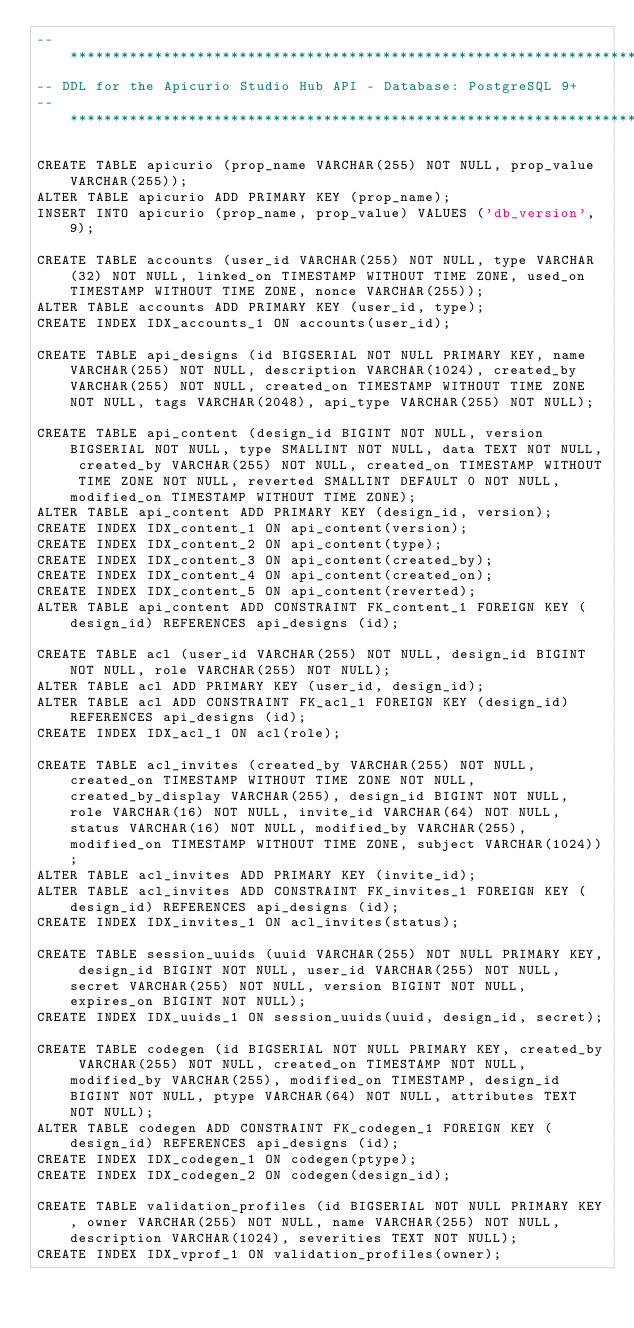Convert code to text. <code><loc_0><loc_0><loc_500><loc_500><_SQL_>-- *********************************************************************
-- DDL for the Apicurio Studio Hub API - Database: PostgreSQL 9+
-- *********************************************************************

CREATE TABLE apicurio (prop_name VARCHAR(255) NOT NULL, prop_value VARCHAR(255));
ALTER TABLE apicurio ADD PRIMARY KEY (prop_name);
INSERT INTO apicurio (prop_name, prop_value) VALUES ('db_version', 9);

CREATE TABLE accounts (user_id VARCHAR(255) NOT NULL, type VARCHAR(32) NOT NULL, linked_on TIMESTAMP WITHOUT TIME ZONE, used_on TIMESTAMP WITHOUT TIME ZONE, nonce VARCHAR(255));
ALTER TABLE accounts ADD PRIMARY KEY (user_id, type);
CREATE INDEX IDX_accounts_1 ON accounts(user_id);

CREATE TABLE api_designs (id BIGSERIAL NOT NULL PRIMARY KEY, name VARCHAR(255) NOT NULL, description VARCHAR(1024), created_by VARCHAR(255) NOT NULL, created_on TIMESTAMP WITHOUT TIME ZONE NOT NULL, tags VARCHAR(2048), api_type VARCHAR(255) NOT NULL);

CREATE TABLE api_content (design_id BIGINT NOT NULL, version BIGSERIAL NOT NULL, type SMALLINT NOT NULL, data TEXT NOT NULL, created_by VARCHAR(255) NOT NULL, created_on TIMESTAMP WITHOUT TIME ZONE NOT NULL, reverted SMALLINT DEFAULT 0 NOT NULL, modified_on TIMESTAMP WITHOUT TIME ZONE);
ALTER TABLE api_content ADD PRIMARY KEY (design_id, version);
CREATE INDEX IDX_content_1 ON api_content(version);
CREATE INDEX IDX_content_2 ON api_content(type);
CREATE INDEX IDX_content_3 ON api_content(created_by);
CREATE INDEX IDX_content_4 ON api_content(created_on);
CREATE INDEX IDX_content_5 ON api_content(reverted);
ALTER TABLE api_content ADD CONSTRAINT FK_content_1 FOREIGN KEY (design_id) REFERENCES api_designs (id);

CREATE TABLE acl (user_id VARCHAR(255) NOT NULL, design_id BIGINT NOT NULL, role VARCHAR(255) NOT NULL);
ALTER TABLE acl ADD PRIMARY KEY (user_id, design_id);
ALTER TABLE acl ADD CONSTRAINT FK_acl_1 FOREIGN KEY (design_id) REFERENCES api_designs (id);
CREATE INDEX IDX_acl_1 ON acl(role);

CREATE TABLE acl_invites (created_by VARCHAR(255) NOT NULL, created_on TIMESTAMP WITHOUT TIME ZONE NOT NULL, created_by_display VARCHAR(255), design_id BIGINT NOT NULL, role VARCHAR(16) NOT NULL, invite_id VARCHAR(64) NOT NULL, status VARCHAR(16) NOT NULL, modified_by VARCHAR(255), modified_on TIMESTAMP WITHOUT TIME ZONE, subject VARCHAR(1024));
ALTER TABLE acl_invites ADD PRIMARY KEY (invite_id);
ALTER TABLE acl_invites ADD CONSTRAINT FK_invites_1 FOREIGN KEY (design_id) REFERENCES api_designs (id);
CREATE INDEX IDX_invites_1 ON acl_invites(status);

CREATE TABLE session_uuids (uuid VARCHAR(255) NOT NULL PRIMARY KEY, design_id BIGINT NOT NULL, user_id VARCHAR(255) NOT NULL, secret VARCHAR(255) NOT NULL, version BIGINT NOT NULL, expires_on BIGINT NOT NULL);
CREATE INDEX IDX_uuids_1 ON session_uuids(uuid, design_id, secret);

CREATE TABLE codegen (id BIGSERIAL NOT NULL PRIMARY KEY, created_by VARCHAR(255) NOT NULL, created_on TIMESTAMP NOT NULL, modified_by VARCHAR(255), modified_on TIMESTAMP, design_id BIGINT NOT NULL, ptype VARCHAR(64) NOT NULL, attributes TEXT NOT NULL);
ALTER TABLE codegen ADD CONSTRAINT FK_codegen_1 FOREIGN KEY (design_id) REFERENCES api_designs (id);
CREATE INDEX IDX_codegen_1 ON codegen(ptype);
CREATE INDEX IDX_codegen_2 ON codegen(design_id);

CREATE TABLE validation_profiles (id BIGSERIAL NOT NULL PRIMARY KEY, owner VARCHAR(255) NOT NULL, name VARCHAR(255) NOT NULL, description VARCHAR(1024), severities TEXT NOT NULL);
CREATE INDEX IDX_vprof_1 ON validation_profiles(owner);
</code> 